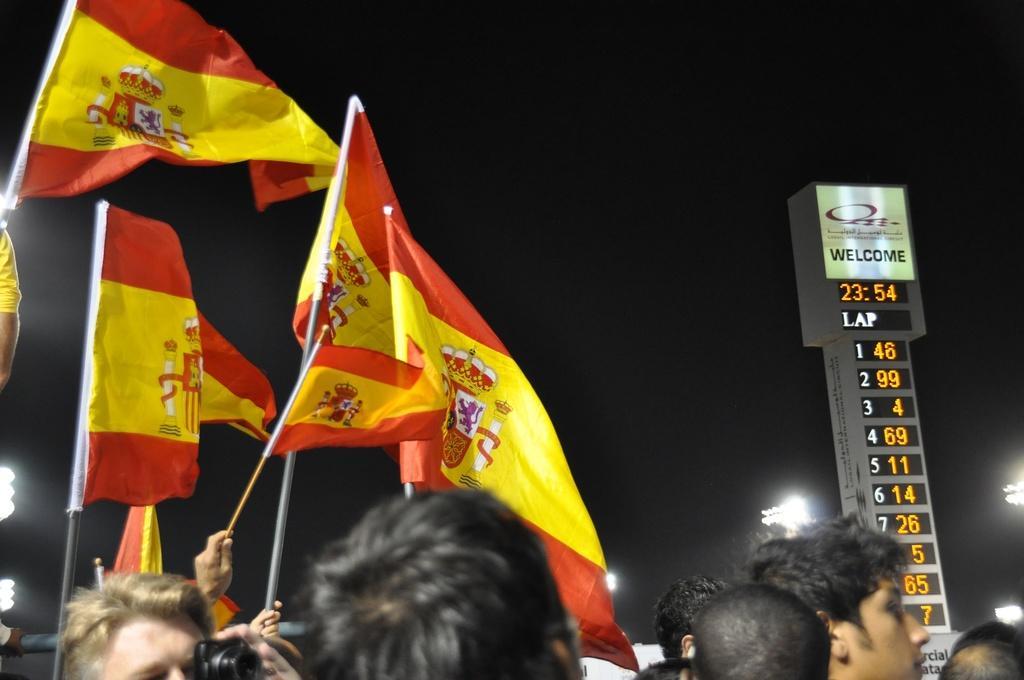Please provide a concise description of this image. In this image there are group of people holding the flags , and in the background there is a scoreboard , lights, poles,sky. 